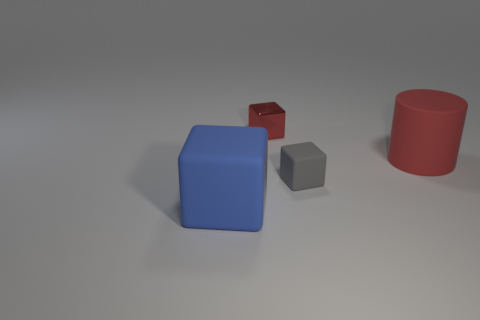Are there any other things that are the same material as the red cube?
Give a very brief answer. No. How many objects are both in front of the red metal object and on the left side of the tiny gray rubber object?
Make the answer very short. 1. What shape is the big blue object?
Keep it short and to the point. Cube. How many other objects are the same material as the tiny red block?
Your answer should be very brief. 0. The big rubber thing right of the large block to the left of the rubber cube right of the blue rubber thing is what color?
Give a very brief answer. Red. What is the material of the blue thing that is the same size as the rubber cylinder?
Your answer should be very brief. Rubber. How many things are either things in front of the red rubber thing or matte cylinders?
Keep it short and to the point. 3. Are any big green blocks visible?
Your answer should be very brief. No. There is a large object to the right of the metallic object; what is it made of?
Give a very brief answer. Rubber. There is a small block that is the same color as the cylinder; what material is it?
Give a very brief answer. Metal. 